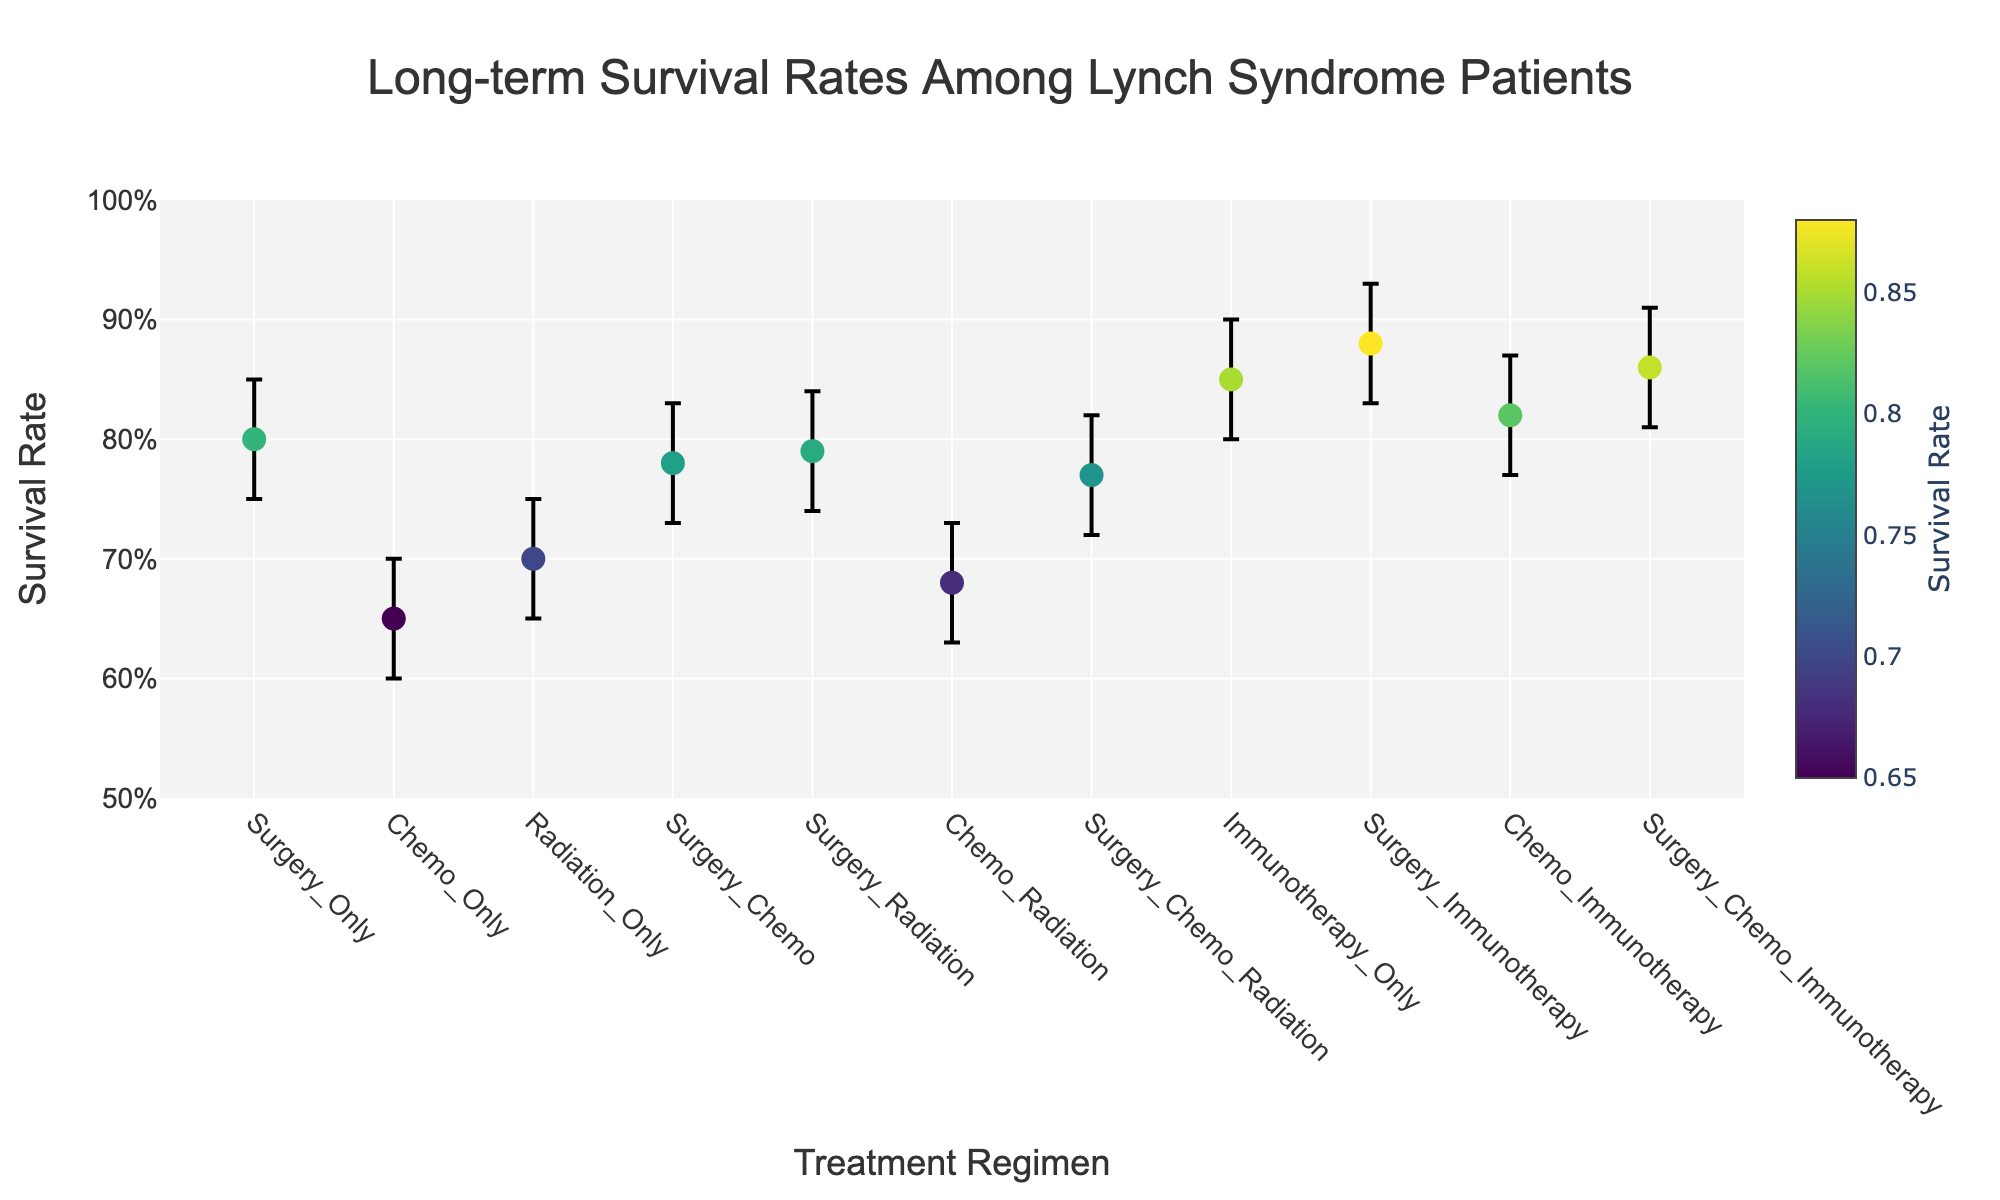What is the title of the figure? The title of the figure can be found at the top of the plot. The text says "Long-term Survival Rates Among Lynch Syndrome Patients."
Answer: Long-term Survival Rates Among Lynch Syndrome Patients What is the survival rate for the immunotherapy-only treatment? To find the survival rate for the immunotherapy-only treatment, look for the data point labeled "Immunotherapy_Only" on the x-axis and check the corresponding y-value, which is 0.85.
Answer: 0.85 Which treatment regimen has the highest survival rate? To find the regimen with the highest survival rate, compare the y-values for all the data points. "Surgery_Immunotherapy" has the highest y-value of 0.88.
Answer: Surgery_Immunotherapy What is the range (difference between upper and lower bounds) for the chemo-immunotherapy treatment? Find the data point for "Chemo_Immunotherapy" and check the lower and upper bounds, which are 0.77 and 0.87, respectively. The range is 0.87 - 0.77 = 0.10.
Answer: 0.10 How many treatment regimens have a survival rate above 80%? To determine how many regimens have survival rates above 80%, count the data points with y-values greater than 0.80. These regimens are "Immunotherapy_Only," "Surgery_Immunotherapy," "Chemo_Immunotherapy," and "Surgery_Chemo_Immunotherapy." There are 4 in total.
Answer: 4 Which treatment regimen has the smallest error margin and what is its value? To find the regimen with the smallest error margin, compare the differences between the upper and lower bounds for each treatment. "Surgery_Only" has bounds from 0.75 to 0.85, resulting in an error margin of 0.10.
Answer: Surgery_Only, 0.10 What is the average survival rate of all treatment regimens? Sum up the survival rates of all regimens and then divide by the number of regimens: (0.80 + 0.65 + 0.70 + 0.78 + 0.79 + 0.68 + 0.77 + 0.85 + 0.88 + 0.82 + 0.86) / 11 = 8.58 / 11 ≈ 0.78.
Answer: 0.78 Which treatment regimen has the widest range of survival rates between the lower and upper bounds? To find the widest range, calculate the difference between the upper and lower bounds for each regimen and determine the maximum value. "Chemo_Immunotherapy" has the widest range of 0.87 - 0.77 = 0.10.
Answer: Chemo_Immunotherapy How does the survival rate of surgery-only compare to chemo-only? Compare the y-values for "Surgery_Only" (0.80) and "Chemo_Only" (0.65). Surgery-only has a higher survival rate.
Answer: Surgery_Only has a higher rate What is the survival rate for surgery combined with chemo and radiation? Find the data point for "Surgery_Chemo_Radiation" and check the corresponding y-value, which is 0.77.
Answer: 0.77 